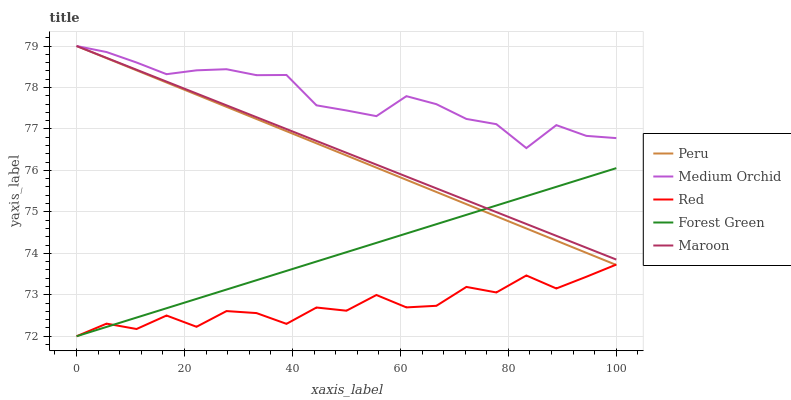Does Red have the minimum area under the curve?
Answer yes or no. Yes. Does Medium Orchid have the maximum area under the curve?
Answer yes or no. Yes. Does Forest Green have the minimum area under the curve?
Answer yes or no. No. Does Forest Green have the maximum area under the curve?
Answer yes or no. No. Is Forest Green the smoothest?
Answer yes or no. Yes. Is Red the roughest?
Answer yes or no. Yes. Is Medium Orchid the smoothest?
Answer yes or no. No. Is Medium Orchid the roughest?
Answer yes or no. No. Does Forest Green have the lowest value?
Answer yes or no. Yes. Does Medium Orchid have the lowest value?
Answer yes or no. No. Does Peru have the highest value?
Answer yes or no. Yes. Does Forest Green have the highest value?
Answer yes or no. No. Is Red less than Medium Orchid?
Answer yes or no. Yes. Is Medium Orchid greater than Forest Green?
Answer yes or no. Yes. Does Peru intersect Maroon?
Answer yes or no. Yes. Is Peru less than Maroon?
Answer yes or no. No. Is Peru greater than Maroon?
Answer yes or no. No. Does Red intersect Medium Orchid?
Answer yes or no. No. 